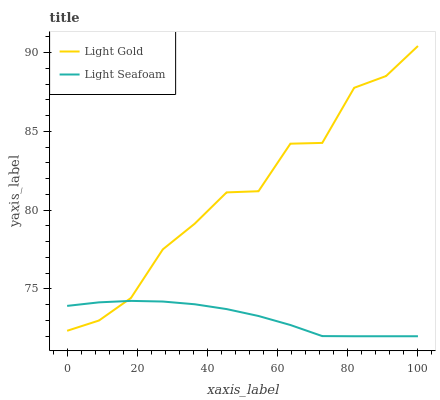Does Light Seafoam have the minimum area under the curve?
Answer yes or no. Yes. Does Light Gold have the maximum area under the curve?
Answer yes or no. Yes. Does Light Gold have the minimum area under the curve?
Answer yes or no. No. Is Light Seafoam the smoothest?
Answer yes or no. Yes. Is Light Gold the roughest?
Answer yes or no. Yes. Is Light Gold the smoothest?
Answer yes or no. No. Does Light Seafoam have the lowest value?
Answer yes or no. Yes. Does Light Gold have the lowest value?
Answer yes or no. No. Does Light Gold have the highest value?
Answer yes or no. Yes. Does Light Gold intersect Light Seafoam?
Answer yes or no. Yes. Is Light Gold less than Light Seafoam?
Answer yes or no. No. Is Light Gold greater than Light Seafoam?
Answer yes or no. No. 